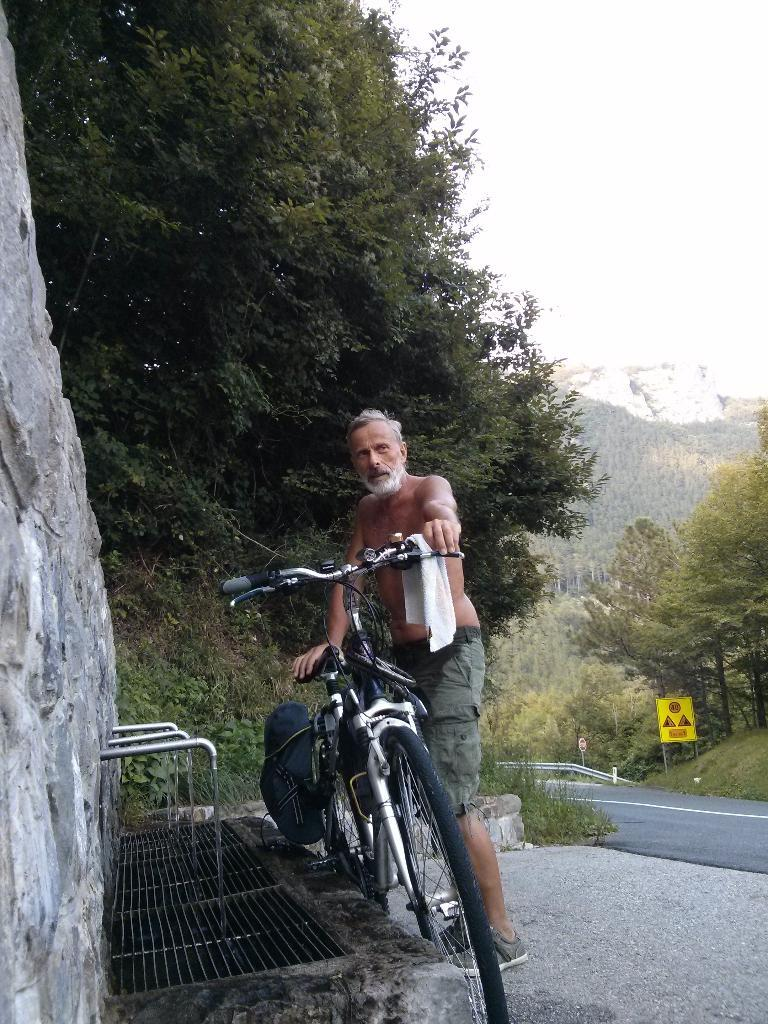Who is present in the image? There is a man in the image. What is the man holding in the image? The man is holding a cycle. What can be seen behind the man in the image? There is a wall in the image. What is visible in the distance in the image? There is a road and trees visible in the background of the image. What type of trade is being conducted in the image? There is no trade being conducted in the image; it features a man holding a cycle with a wall and a road visible in the background. 